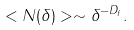Convert formula to latex. <formula><loc_0><loc_0><loc_500><loc_500>< N ( \delta ) > \sim \delta ^ { - D _ { f } } .</formula> 